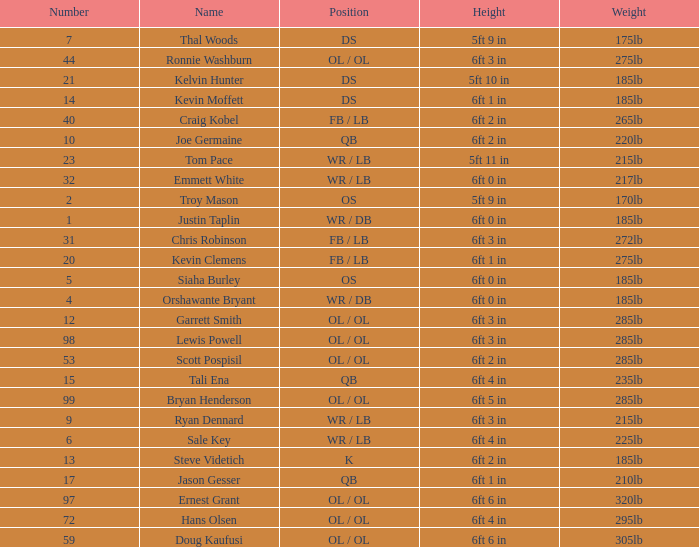What is the number for the player that has a k position? 13.0. 